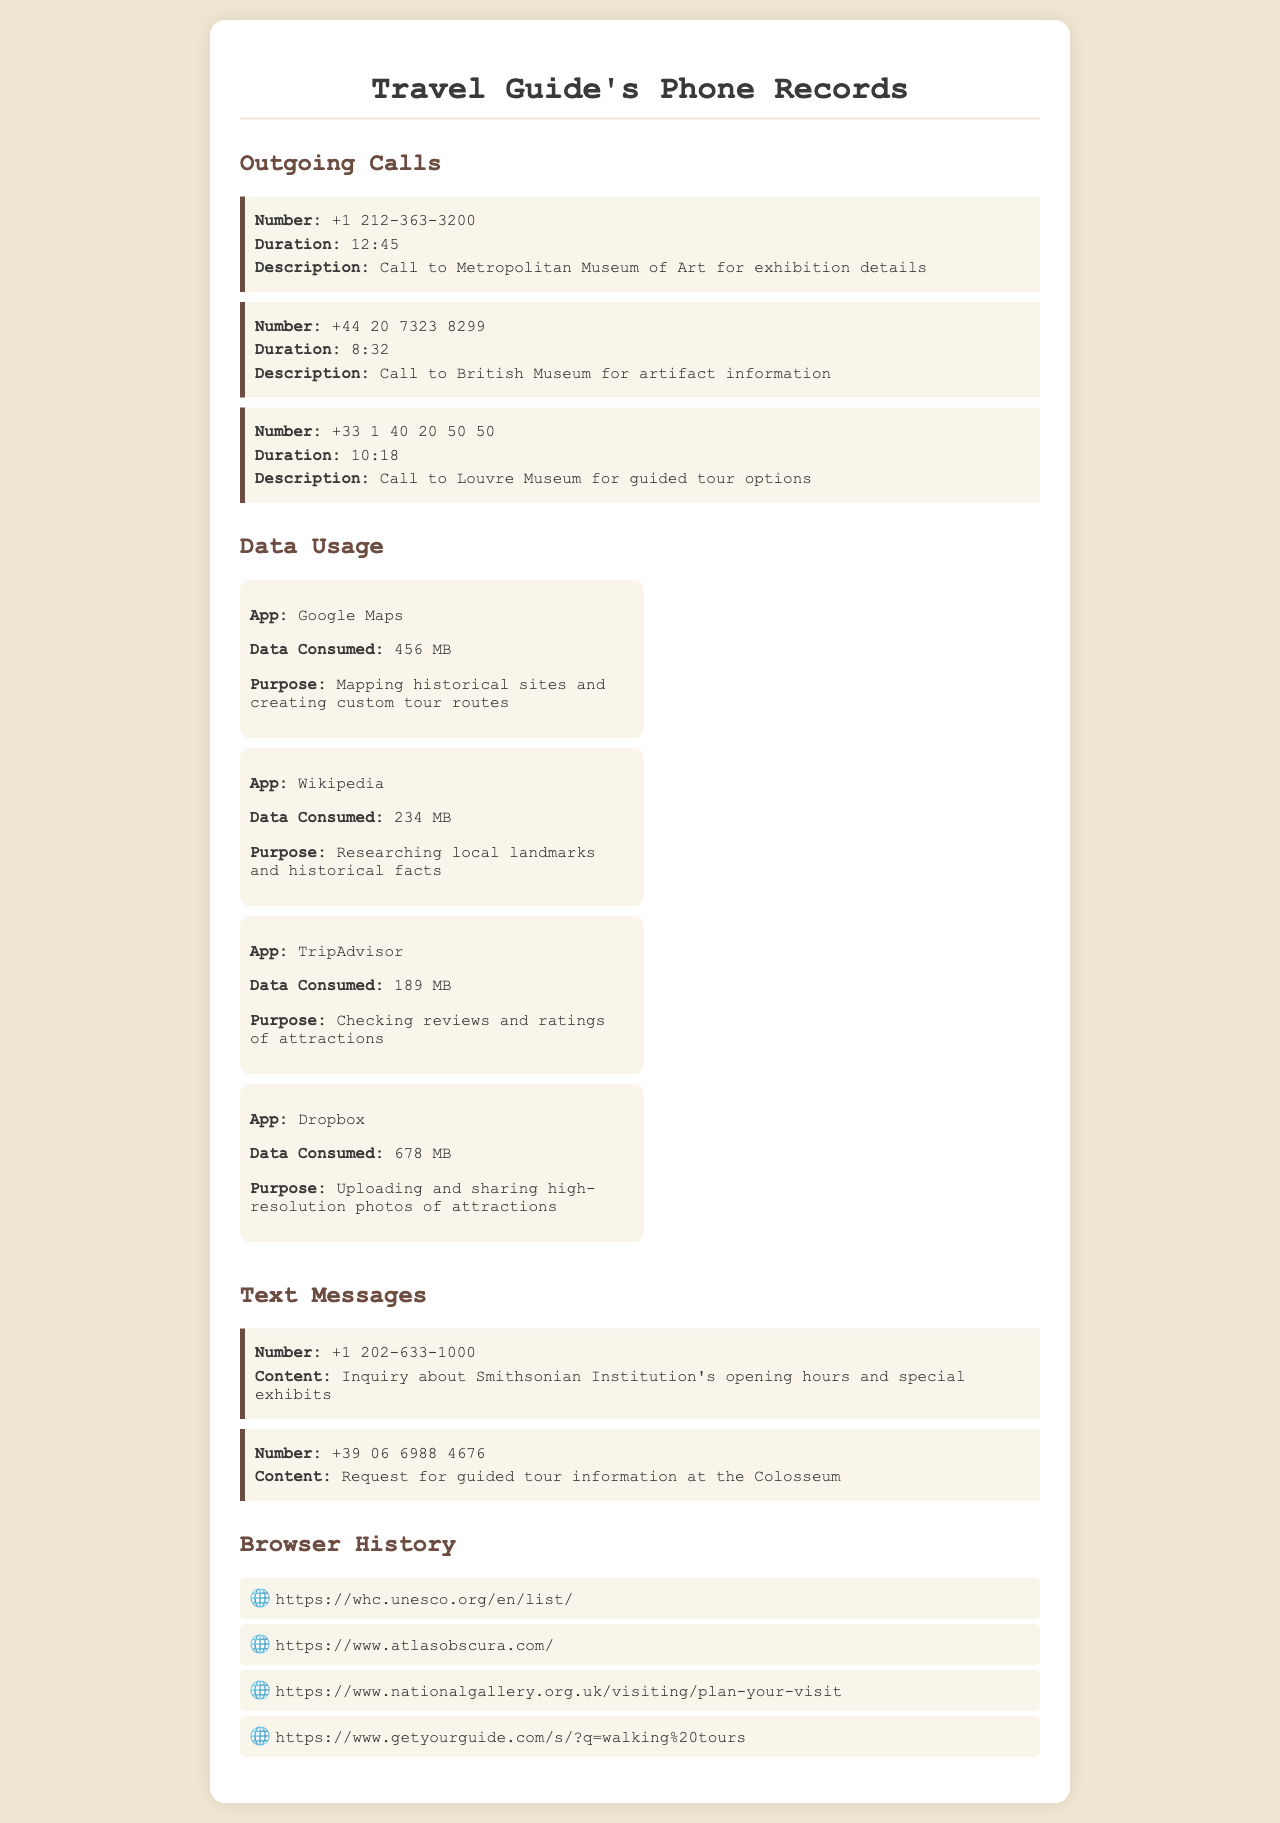What was the duration of the call to the Louvre Museum? The duration of the call to the Louvre Museum is listed as 10:18.
Answer: 10:18 How much data was consumed by Google Maps? The total data consumed by Google Maps is specified as 456 MB.
Answer: 456 MB Which app consumed the most data? The app with the highest data consumption is Dropbox, using 678 MB.
Answer: Dropbox What was the purpose of using Wikipedia? The purpose of using Wikipedia was for researching local landmarks and historical facts.
Answer: Researching local landmarks and historical facts How many text messages are recorded in the document? There are two text messages recorded in the document.
Answer: Two What phone number was called for artifact information? The phone number called for artifact information is +44 20 7323 8299.
Answer: +44 20 7323 8299 What is the URL for planning a visit to the National Gallery? The URL for planning a visit to the National Gallery is listed as https://www.nationalgallery.org.uk/visiting/plan-your-visit.
Answer: https://www.nationalgallery.org.uk/visiting/plan-your-visit What was the duration of the call to the British Museum? The duration of the call to the British Museum was 8:32.
Answer: 8:32 What kind of information was in the text message to the Smithsonian Institution? The inquiry in the text message was about opening hours and special exhibits.
Answer: Opening hours and special exhibits 